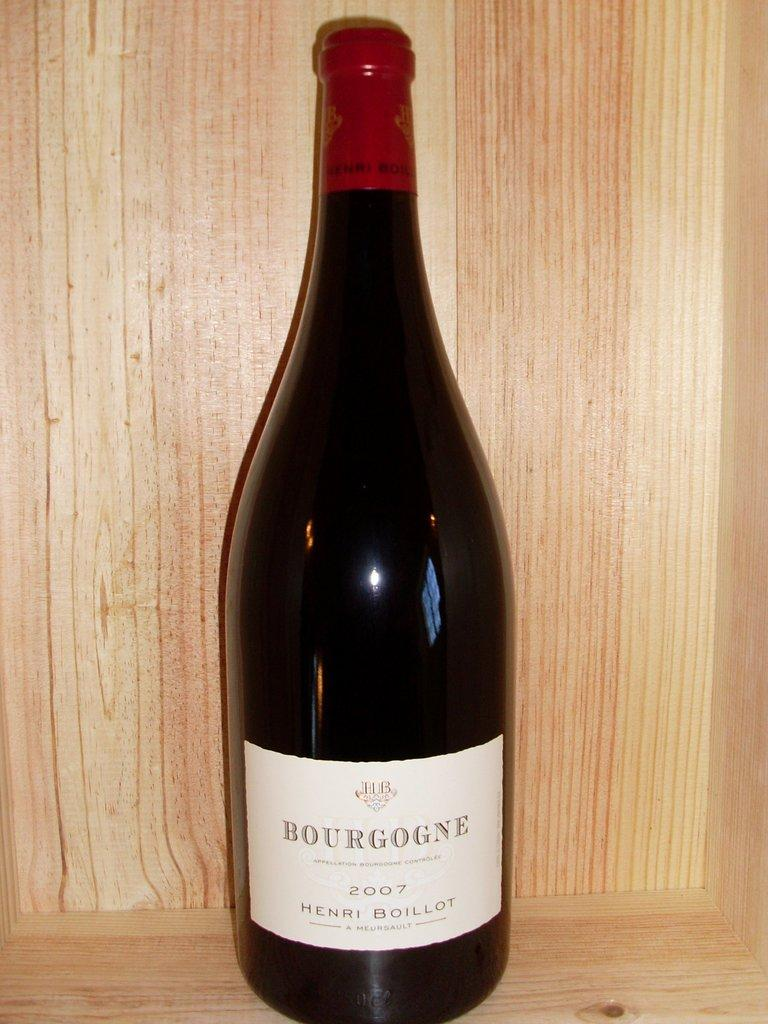<image>
Present a compact description of the photo's key features. A dark colored glass bottle of Henri Boillot Bourgogne with a white label and red foil capping. 